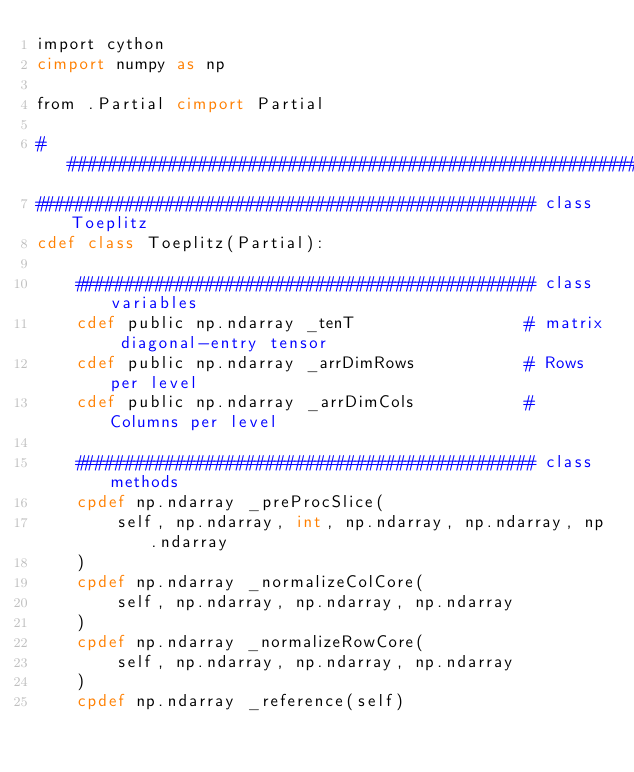<code> <loc_0><loc_0><loc_500><loc_500><_Cython_>import cython
cimport numpy as np

from .Partial cimport Partial

################################################################################
################################################## class Toeplitz
cdef class Toeplitz(Partial):

    ############################################## class variables
    cdef public np.ndarray _tenT                 # matrix diagonal-entry tensor
    cdef public np.ndarray _arrDimRows           # Rows per level
    cdef public np.ndarray _arrDimCols           # Columns per level

    ############################################## class methods
    cpdef np.ndarray _preProcSlice(
        self, np.ndarray, int, np.ndarray, np.ndarray, np.ndarray
    )
    cpdef np.ndarray _normalizeColCore(
        self, np.ndarray, np.ndarray, np.ndarray
    )
    cpdef np.ndarray _normalizeRowCore(
        self, np.ndarray, np.ndarray, np.ndarray
    )
    cpdef np.ndarray _reference(self)
</code> 